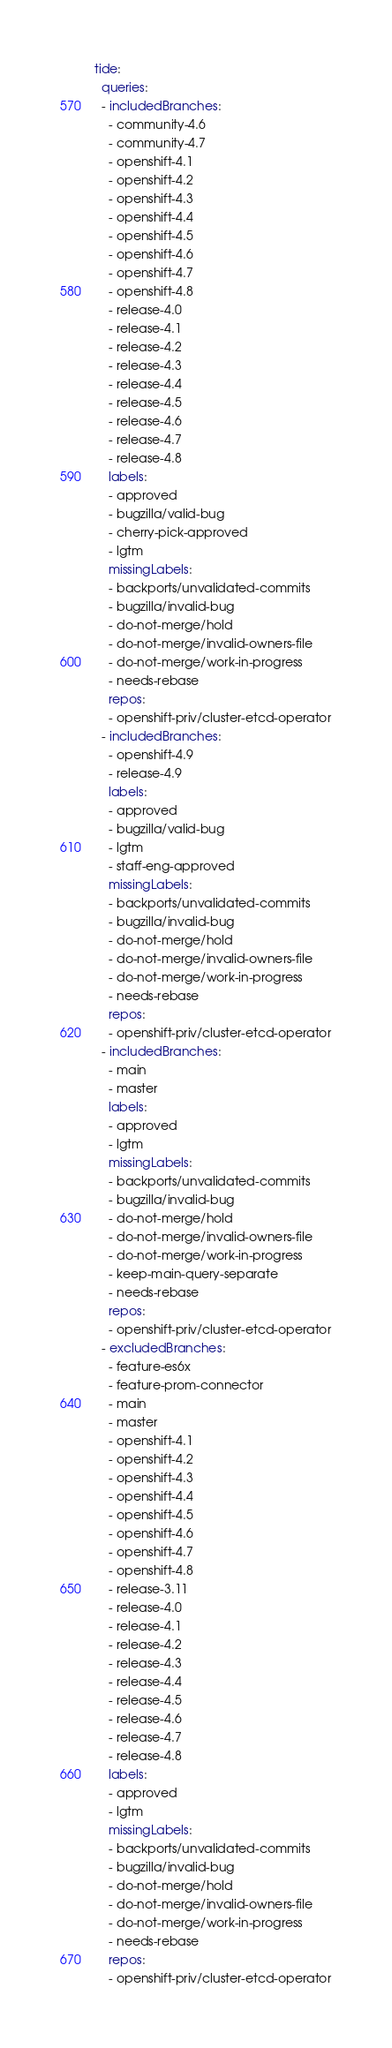<code> <loc_0><loc_0><loc_500><loc_500><_YAML_>tide:
  queries:
  - includedBranches:
    - community-4.6
    - community-4.7
    - openshift-4.1
    - openshift-4.2
    - openshift-4.3
    - openshift-4.4
    - openshift-4.5
    - openshift-4.6
    - openshift-4.7
    - openshift-4.8
    - release-4.0
    - release-4.1
    - release-4.2
    - release-4.3
    - release-4.4
    - release-4.5
    - release-4.6
    - release-4.7
    - release-4.8
    labels:
    - approved
    - bugzilla/valid-bug
    - cherry-pick-approved
    - lgtm
    missingLabels:
    - backports/unvalidated-commits
    - bugzilla/invalid-bug
    - do-not-merge/hold
    - do-not-merge/invalid-owners-file
    - do-not-merge/work-in-progress
    - needs-rebase
    repos:
    - openshift-priv/cluster-etcd-operator
  - includedBranches:
    - openshift-4.9
    - release-4.9
    labels:
    - approved
    - bugzilla/valid-bug
    - lgtm
    - staff-eng-approved
    missingLabels:
    - backports/unvalidated-commits
    - bugzilla/invalid-bug
    - do-not-merge/hold
    - do-not-merge/invalid-owners-file
    - do-not-merge/work-in-progress
    - needs-rebase
    repos:
    - openshift-priv/cluster-etcd-operator
  - includedBranches:
    - main
    - master
    labels:
    - approved
    - lgtm
    missingLabels:
    - backports/unvalidated-commits
    - bugzilla/invalid-bug
    - do-not-merge/hold
    - do-not-merge/invalid-owners-file
    - do-not-merge/work-in-progress
    - keep-main-query-separate
    - needs-rebase
    repos:
    - openshift-priv/cluster-etcd-operator
  - excludedBranches:
    - feature-es6x
    - feature-prom-connector
    - main
    - master
    - openshift-4.1
    - openshift-4.2
    - openshift-4.3
    - openshift-4.4
    - openshift-4.5
    - openshift-4.6
    - openshift-4.7
    - openshift-4.8
    - release-3.11
    - release-4.0
    - release-4.1
    - release-4.2
    - release-4.3
    - release-4.4
    - release-4.5
    - release-4.6
    - release-4.7
    - release-4.8
    labels:
    - approved
    - lgtm
    missingLabels:
    - backports/unvalidated-commits
    - bugzilla/invalid-bug
    - do-not-merge/hold
    - do-not-merge/invalid-owners-file
    - do-not-merge/work-in-progress
    - needs-rebase
    repos:
    - openshift-priv/cluster-etcd-operator
</code> 